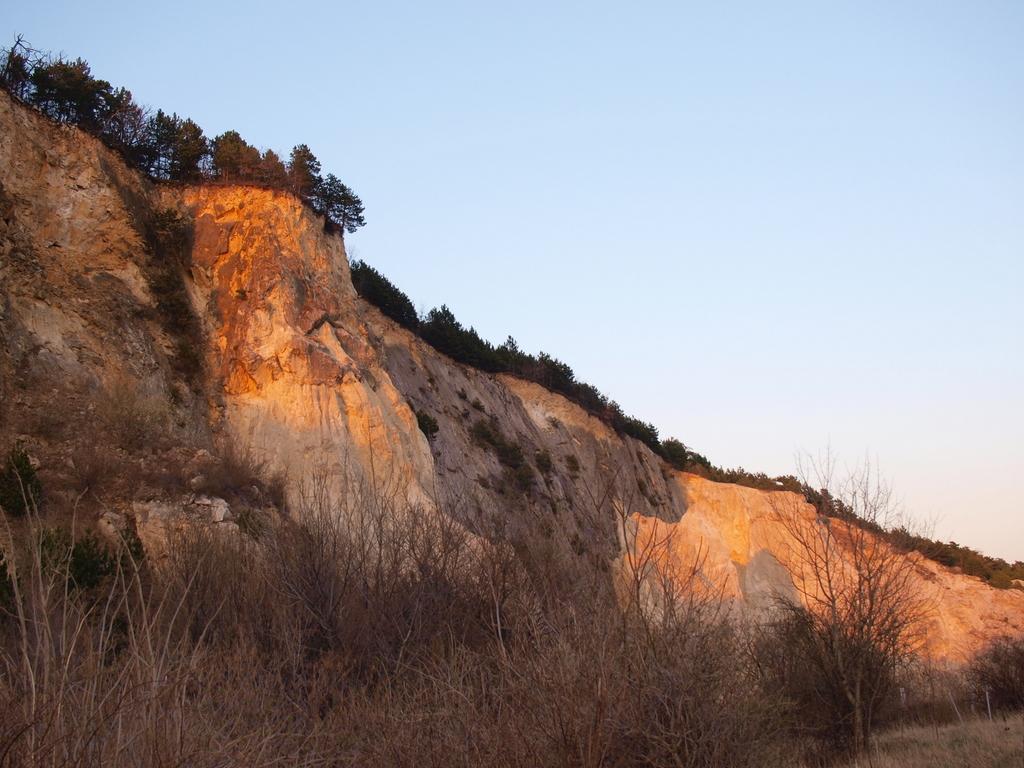How would you summarize this image in a sentence or two? In this image there is a big rock mountain with the trees on top and some dried plants at bottom. 